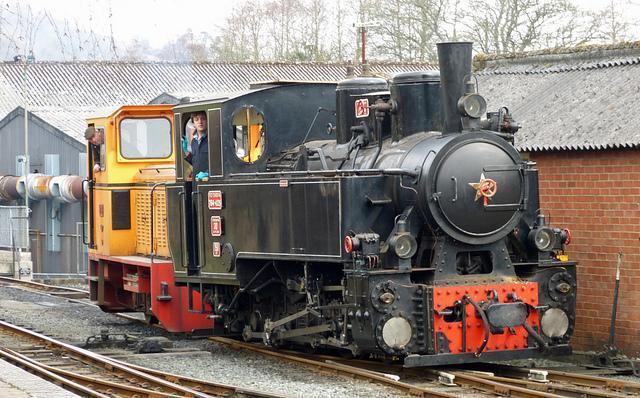How many people are in this photo?
Give a very brief answer. 1. 